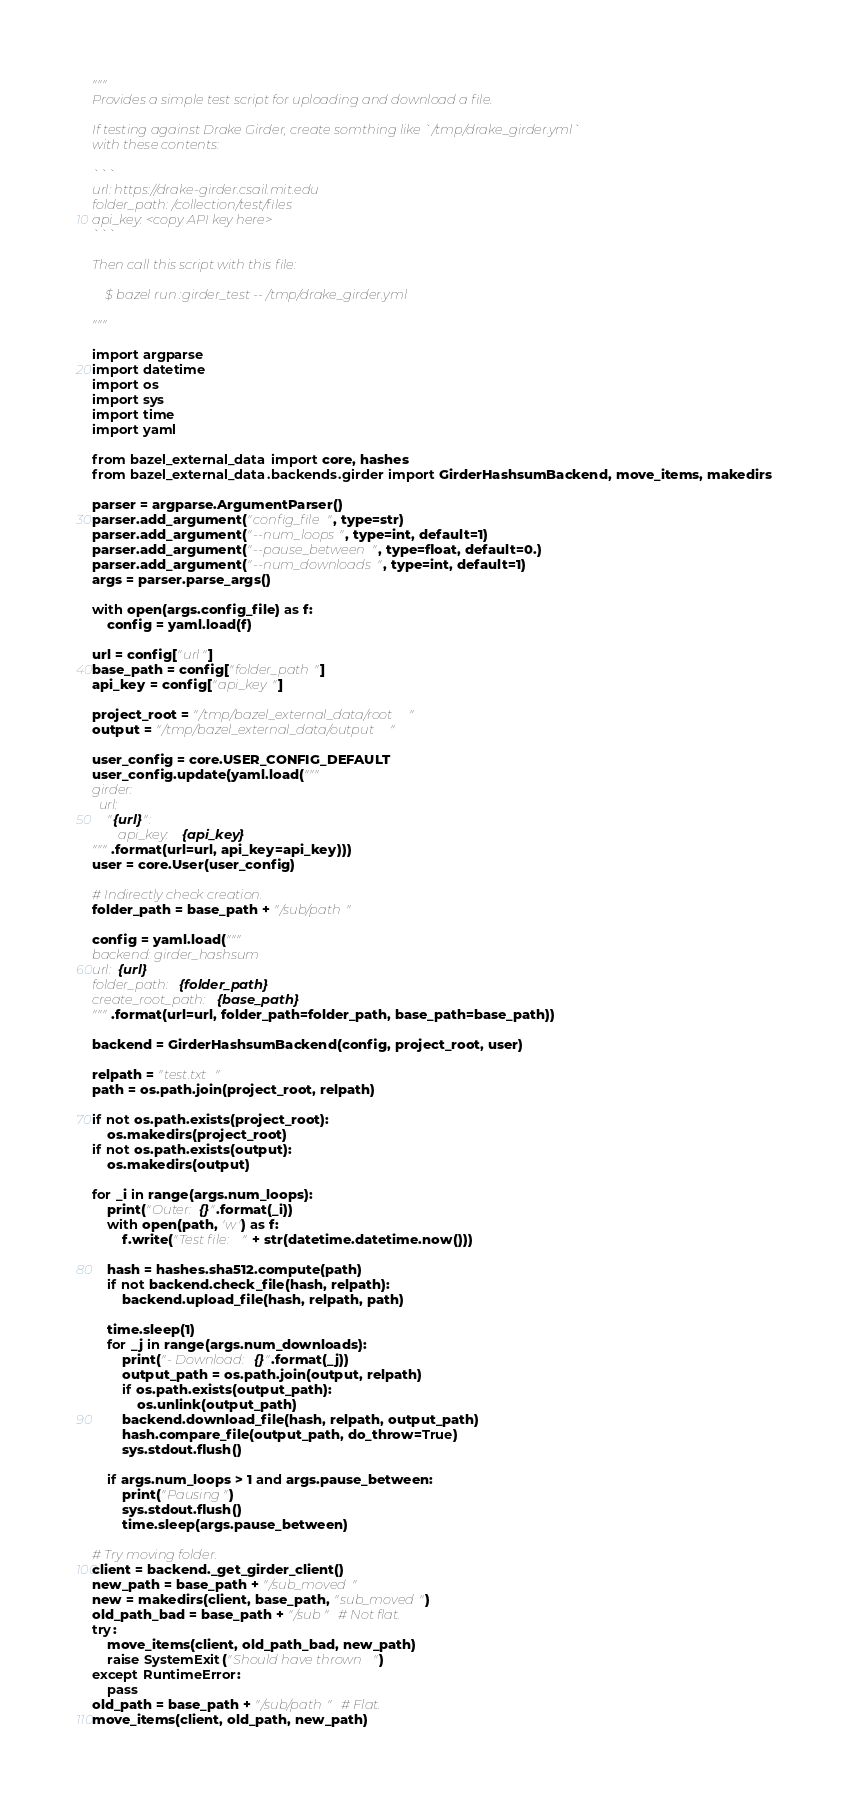Convert code to text. <code><loc_0><loc_0><loc_500><loc_500><_Python_>"""
Provides a simple test script for uploading and download a file.

If testing against Drake Girder, create somthing like `/tmp/drake_girder.yml`
with these contents:

```
url: https://drake-girder.csail.mit.edu
folder_path: /collection/test/files
api_key: <copy API key here>
```

Then call this script with this file:

    $ bazel run :girder_test -- /tmp/drake_girder.yml

"""

import argparse
import datetime
import os
import sys
import time
import yaml

from bazel_external_data import core, hashes
from bazel_external_data.backends.girder import GirderHashsumBackend, move_items, makedirs

parser = argparse.ArgumentParser()
parser.add_argument("config_file", type=str)
parser.add_argument("--num_loops", type=int, default=1)
parser.add_argument("--pause_between", type=float, default=0.)
parser.add_argument("--num_downloads", type=int, default=1)
args = parser.parse_args()

with open(args.config_file) as f:
    config = yaml.load(f)

url = config["url"]
base_path = config["folder_path"]
api_key = config["api_key"]

project_root = "/tmp/bazel_external_data/root"
output = "/tmp/bazel_external_data/output"

user_config = core.USER_CONFIG_DEFAULT
user_config.update(yaml.load("""
girder:
  url:
    "{url}":
        api_key: {api_key}
""".format(url=url, api_key=api_key)))
user = core.User(user_config)

# Indirectly check creation.
folder_path = base_path + "/sub/path"

config = yaml.load("""
backend: girder_hashsum
url: {url}
folder_path: {folder_path}
create_root_path: {base_path}
""".format(url=url, folder_path=folder_path, base_path=base_path))

backend = GirderHashsumBackend(config, project_root, user)

relpath = "test.txt"
path = os.path.join(project_root, relpath)

if not os.path.exists(project_root):
    os.makedirs(project_root)
if not os.path.exists(output):
    os.makedirs(output)

for _i in range(args.num_loops):
    print("Outer: {}".format(_i))
    with open(path, 'w') as f:
        f.write("Test file: " + str(datetime.datetime.now()))

    hash = hashes.sha512.compute(path)
    if not backend.check_file(hash, relpath):
        backend.upload_file(hash, relpath, path)

    time.sleep(1)
    for _j in range(args.num_downloads):
        print("- Download: {}".format(_j))
        output_path = os.path.join(output, relpath)
        if os.path.exists(output_path):
            os.unlink(output_path)
        backend.download_file(hash, relpath, output_path)
        hash.compare_file(output_path, do_throw=True)
        sys.stdout.flush()

    if args.num_loops > 1 and args.pause_between:
        print("Pausing")
        sys.stdout.flush()
        time.sleep(args.pause_between)

# Try moving folder.
client = backend._get_girder_client()
new_path = base_path + "/sub_moved"
new = makedirs(client, base_path, "sub_moved")
old_path_bad = base_path + "/sub"  # Not flat.
try:
    move_items(client, old_path_bad, new_path)
    raise SystemExit("Should have thrown")
except RuntimeError:
    pass
old_path = base_path + "/sub/path"  # Flat.
move_items(client, old_path, new_path)
</code> 